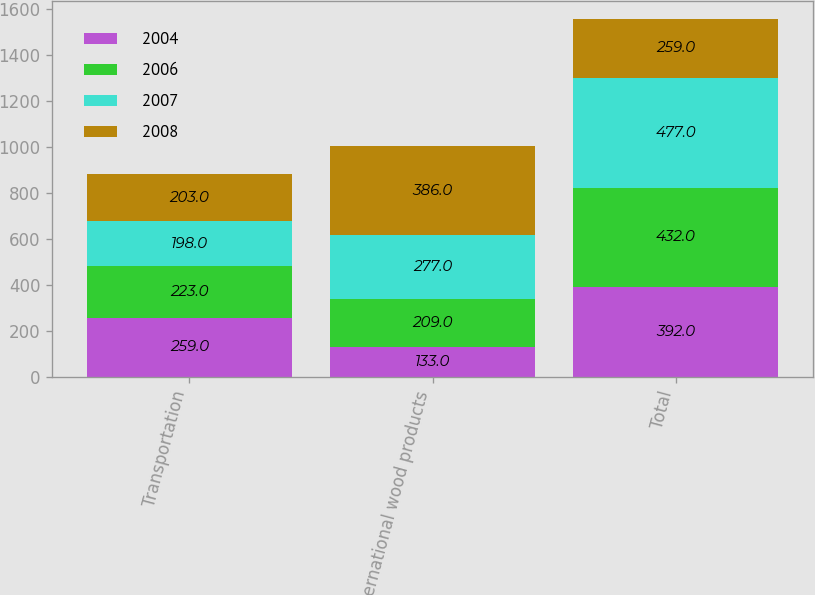<chart> <loc_0><loc_0><loc_500><loc_500><stacked_bar_chart><ecel><fcel>Transportation<fcel>International wood products<fcel>Total<nl><fcel>2004<fcel>259<fcel>133<fcel>392<nl><fcel>2006<fcel>223<fcel>209<fcel>432<nl><fcel>2007<fcel>198<fcel>277<fcel>477<nl><fcel>2008<fcel>203<fcel>386<fcel>259<nl></chart> 